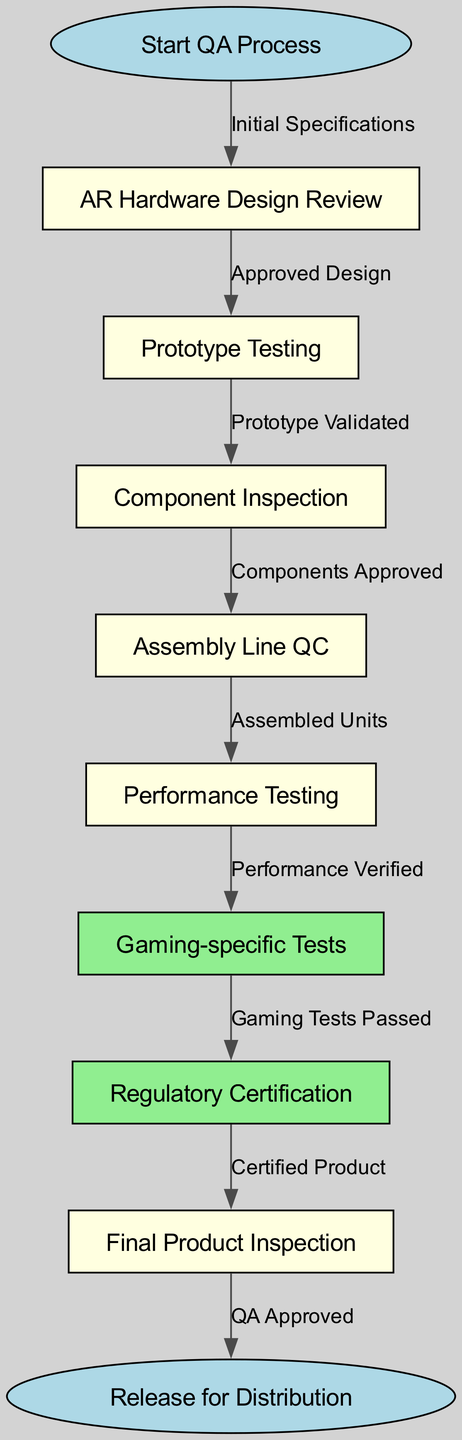What is the first step in the QA process? The first node in the diagram indicates the beginning of the quality assurance process is "Start QA Process."
Answer: Start QA Process How many total nodes are there in the diagram? By counting all distinct nodes listed in the diagram, we find there are 10 nodes present in total.
Answer: 10 What is the node that follows "Prototype Testing"? Following "Prototype Testing" in the flow, the next node is "Component Inspection."
Answer: Component Inspection What does the edge between "Performance Testing" and "Gaming-specific Tests" represent? The edge signifies the relationship where "Performance Testing" must be completed and verified before proceeding to "Gaming-specific Tests."
Answer: Performance Verified Which step immediately precedes "Regulatory Certification"? The step just before "Regulatory Certification" in the flow is "Gaming-specific Tests," indicating that gaming tests must be passed prior to certification.
Answer: Gaming Tests Passed What happens after "Final Product Inspection"? The flow chart shows that after "Final Product Inspection," the subsequent step is "Release for Distribution."
Answer: Release for Distribution If "Prototype Testing" is not validated, which step is affected? If "Prototype Testing" is not validated, it directly affects "Component Inspection," halting the progress to the next steps.
Answer: Component Inspection Which nodes are associated with QA approvals? The nodes associated with QA approvals are "Final Product Inspection" and "Release for Distribution," indicating their critical roles in the approval process.
Answer: Final Product Inspection, Release for Distribution What indicates the successful passing of gaming tests? The successful passing of gaming tests is indicated by the connection from "Gaming-specific Tests" to "Regulatory Certification," demonstrating the criteria for moving forward.
Answer: Gaming Tests Passed 